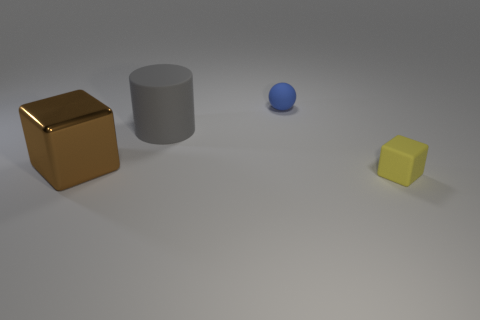How many spheres are either small blue objects or large gray matte objects?
Your answer should be compact. 1. Are there an equal number of large gray cylinders to the left of the big metallic object and blocks that are right of the matte block?
Give a very brief answer. Yes. There is a large thing that is left of the big thing that is behind the large brown shiny object; how many things are right of it?
Your response must be concise. 3. There is a metal thing; is its color the same as the rubber thing behind the large rubber object?
Your answer should be very brief. No. Is the number of big gray cylinders that are to the right of the gray rubber cylinder greater than the number of large purple blocks?
Keep it short and to the point. No. How many objects are either rubber balls to the right of the cylinder or yellow cubes that are in front of the big cylinder?
Offer a terse response. 2. What size is the cube that is the same material as the sphere?
Your answer should be very brief. Small. There is a thing that is behind the large gray matte thing; is its shape the same as the big rubber thing?
Provide a succinct answer. No. How many cyan things are either balls or large rubber objects?
Make the answer very short. 0. How many other objects are there of the same shape as the gray object?
Your answer should be very brief. 0. 